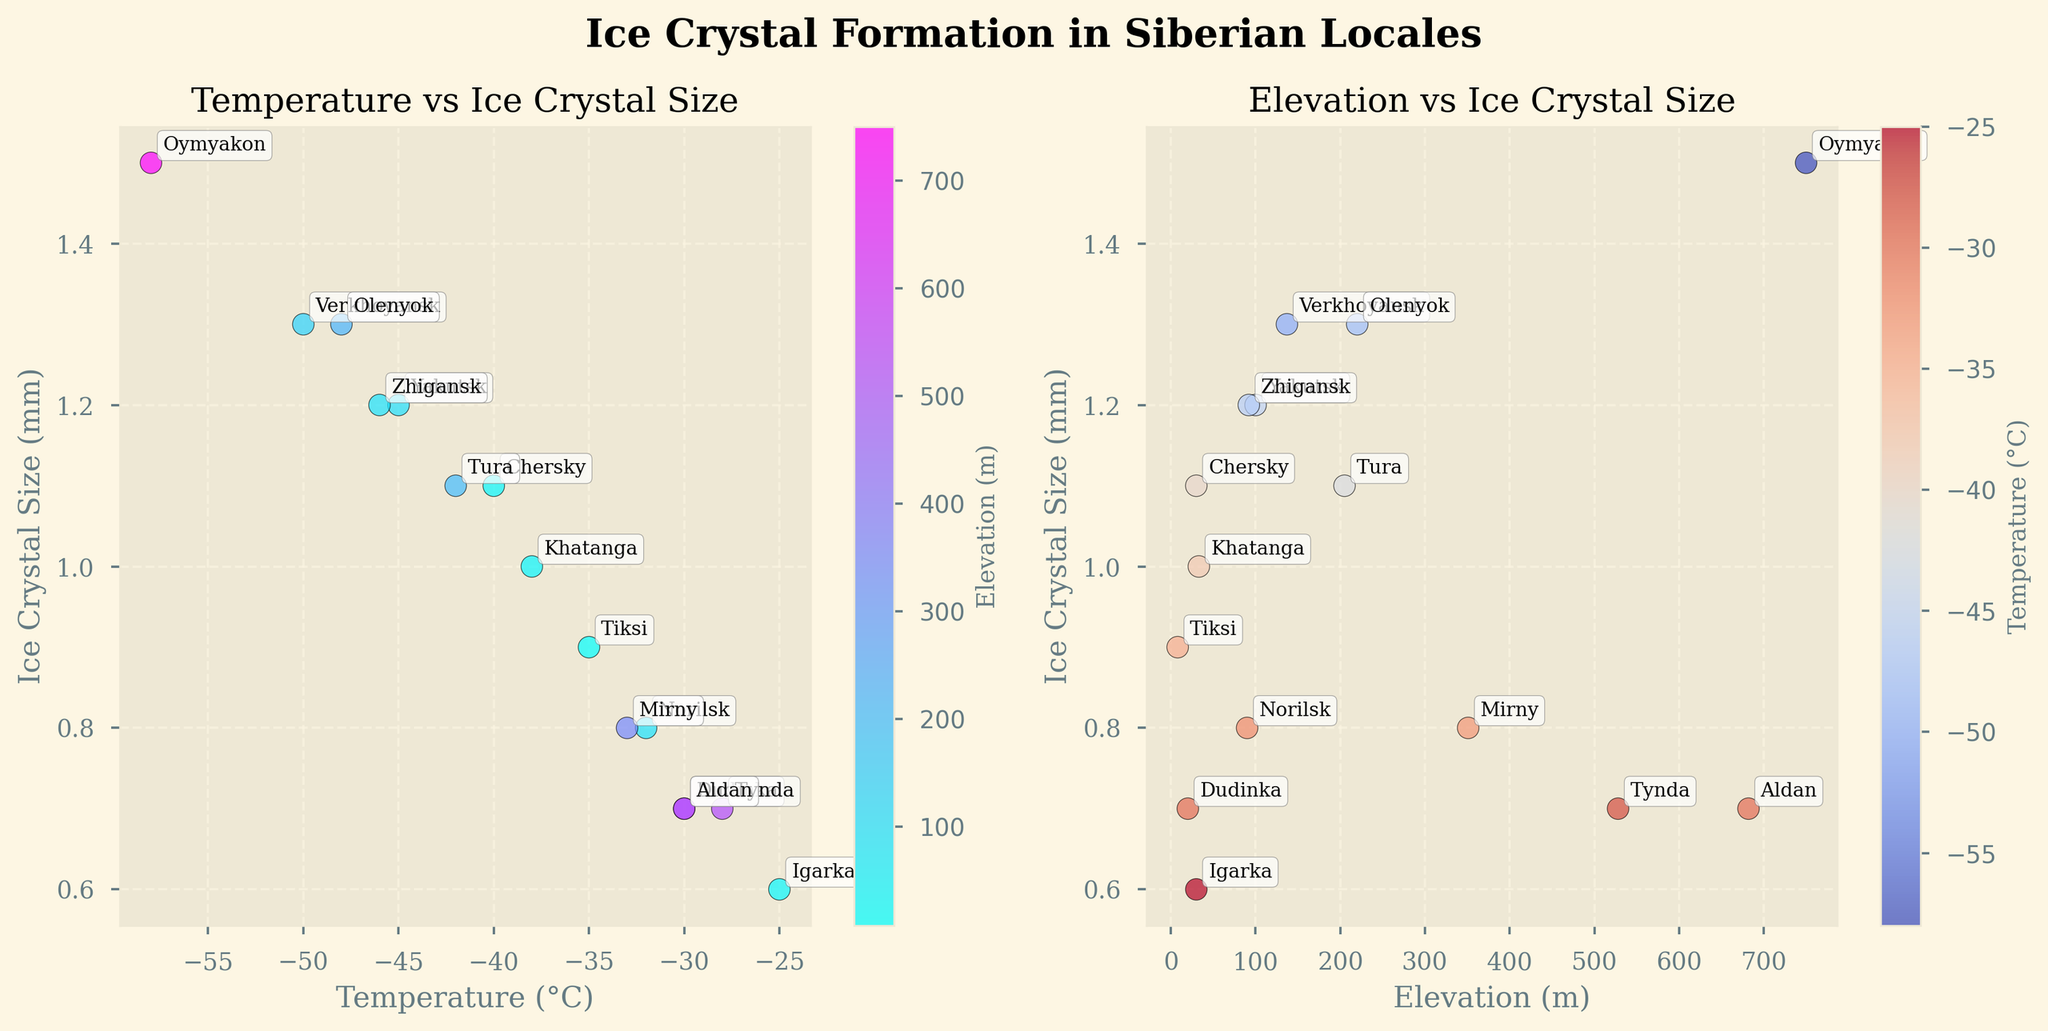What's the title of the figure? The title is displayed prominently at the top of the figure, reading "Ice Crystal Formation in Siberian Locales".
Answer: Ice Crystal Formation in Siberian Locales What is the range of elevation values shown in the second scatter plot? The second scatter plot's x-axis represents elevation, ranging from around 0 to 800 meters.
Answer: Around 0 to 800 meters Which location has the smallest ice crystal size? By looking at the y-axis values of "Ice Crystal Size (mm)" in either scatter plot, Igarka is labeled with 0.6 mm, the smallest value.
Answer: Igarka How many locations have temperatures below -50°C? By examining the temperature axis in the first scatter plot and identifying the data points below -50°C, Yakutsk, Oymyakon, and Verkhoyansk are those locations.
Answer: 3 Which locale has the highest elevation and what is its ice crystal size? Checking the second scatter plot (Elevation vs Ice Crystal Size) for the highest point on the x-axis, Oymyakon has an elevation of 750 m with an ice crystal size of 1.5 mm.
Answer: Oymyakon, 1.5 mm Which location has the largest ice crystal size at the lowest temperature in the first scatter plot? The largest ice crystal size in the lowest temperature in the first scatter plot corresponds to Oymyakon at -58°C with an ice crystal size of 1.5 mm.
Answer: Oymyakon Is there any location with both a high elevation and a small ice crystal size? In the second scatter plot, Tynda has a higher elevation around 528 m and a smaller ice crystal size of 0.7 mm.
Answer: Tynda What is the general relationship between temperature and ice crystal size? Observing the trend in the first scatter plot, it appears that lower temperatures generally result in larger ice crystal sizes.
Answer: Larger crystals at lower temperatures In the second scatter plot, which location has the highest ice crystal size at approximately the same elevation as Chersky? Chersky has an elevation of 30 meters, and Khatanga (33 meters) and Zhigansk (92 meters) show higher ice crystal sizes, with Khatanga having 1.0 mm compared to Chersky's 1.1 mm and Zhigansk's 1.2 mm.
Answer: Zhigansk Between 0.7 mm and 1.1 mm ice crystal sizes, which locales are spread between elevations 0 to 100 meters? The second plot shows the points within a 0.7 mm to 1.1 mm range; locations such as Norilsk (90 m), Chersky (30 m), Dudinka (20 m), Igarka (30 m), and Tura (92 m) fall within this range.
Answer: Norilsk, Chersky, Dudinka, Igarka, Tura 